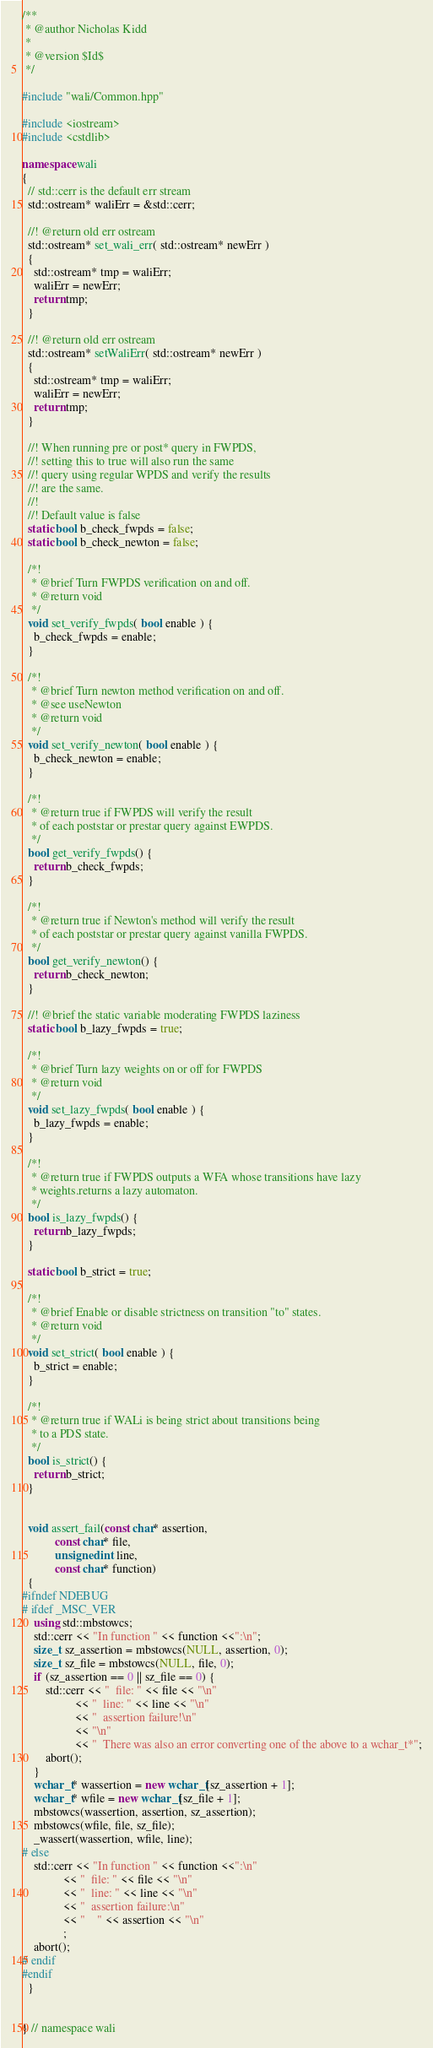Convert code to text. <code><loc_0><loc_0><loc_500><loc_500><_C++_>/**
 * @author Nicholas Kidd
 *
 * @version $Id$
 */

#include "wali/Common.hpp"

#include <iostream>
#include <cstdlib>

namespace wali
{
  // std::cerr is the default err stream
  std::ostream* waliErr = &std::cerr;

  //! @return old err ostream
  std::ostream* set_wali_err( std::ostream* newErr )
  {
    std::ostream* tmp = waliErr;
    waliErr = newErr;
    return tmp;
  }

  //! @return old err ostream
  std::ostream* setWaliErr( std::ostream* newErr )
  {
    std::ostream* tmp = waliErr;
    waliErr = newErr;
    return tmp;
  }

  //! When running pre or post* query in FWPDS,
  //! setting this to true will also run the same
  //! query using regular WPDS and verify the results
  //! are the same.
  //!
  //! Default value is false
  static bool b_check_fwpds = false;
  static bool b_check_newton = false;

  /*!
   * @brief Turn FWPDS verification on and off.
   * @return void
   */
  void set_verify_fwpds( bool enable ) {
    b_check_fwpds = enable;
  }

  /*!
   * @brief Turn newton method verification on and off.
   * @see useNewton
   * @return void
   */
  void set_verify_newton( bool enable ) {
    b_check_newton = enable;
  }

  /*! 
   * @return true if FWPDS will verify the result
   * of each poststar or prestar query against EWPDS.
   */
  bool get_verify_fwpds() {
    return b_check_fwpds;
  }

  /*! 
   * @return true if Newton's method will verify the result
   * of each poststar or prestar query against vanilla FWPDS.
   */
  bool get_verify_newton() {
    return b_check_newton;
  }

  //! @brief the static variable moderating FWPDS laziness
  static bool b_lazy_fwpds = true;

  /*!
   * @brief Turn lazy weights on or off for FWPDS
   * @return void
   */
  void set_lazy_fwpds( bool enable ) {
    b_lazy_fwpds = enable;
  }

  /*! 
   * @return true if FWPDS outputs a WFA whose transitions have lazy
   * weights.returns a lazy automaton.
   */
  bool is_lazy_fwpds() {
    return b_lazy_fwpds;
  }

  static bool b_strict = true;

  /*!
   * @brief Enable or disable strictness on transition "to" states.
   * @return void
   */
  void set_strict( bool enable ) {
    b_strict = enable;
  }

  /*!
   * @return true if WALi is being strict about transitions being
   * to a PDS state.
   */
  bool is_strict() {
    return b_strict;
  }


  void assert_fail(const char* assertion,
		   const char* file,
		   unsigned int line,
		   const char* function)
  {
#ifndef NDEBUG
# ifdef _MSC_VER
    using std::mbstowcs;
    std::cerr << "In function " << function <<":\n";
    size_t sz_assertion = mbstowcs(NULL, assertion, 0);
    size_t sz_file = mbstowcs(NULL, file, 0);
    if (sz_assertion == 0 || sz_file == 0) {
        std::cerr << "  file: " << file << "\n"
                  << "  line: " << line << "\n"
                  << "  assertion failure!\n"
                  << "\n"
                  << "  There was also an error converting one of the above to a wchar_t*";
        abort();
    } 
    wchar_t* wassertion = new wchar_t[sz_assertion + 1];
    wchar_t* wfile = new wchar_t[sz_file + 1];
    mbstowcs(wassertion, assertion, sz_assertion);
    mbstowcs(wfile, file, sz_file);
    _wassert(wassertion, wfile, line);
# else
    std::cerr << "In function " << function <<":\n"
              << "  file: " << file << "\n"
              << "  line: " << line << "\n"
              << "  assertion failure:\n"
              << "    " << assertion << "\n"
              ;
    abort();
# endif
#endif
  }
  

} // namespace wali

</code> 